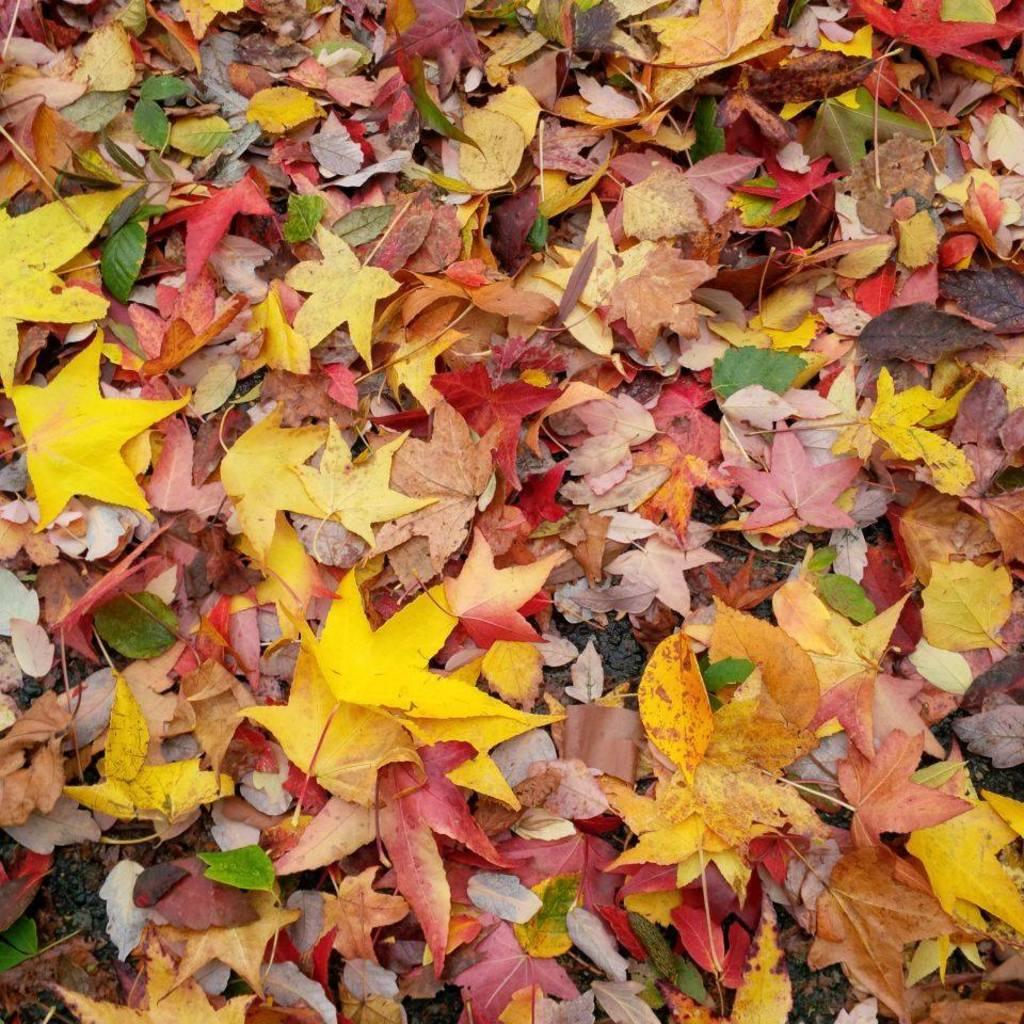Describe this image in one or two sentences. There are different color leaves on the ground. 